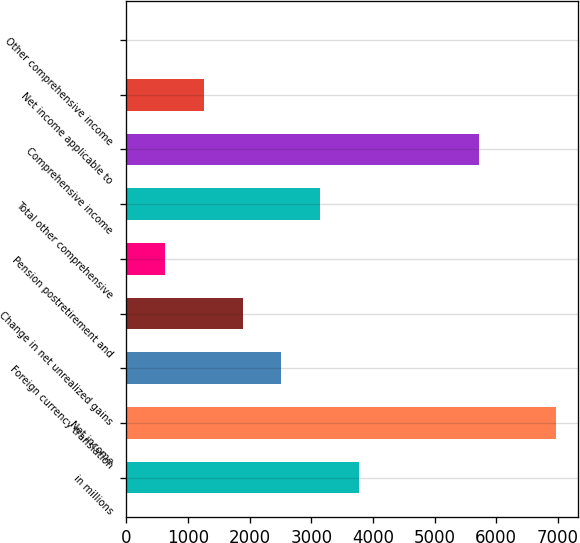Convert chart to OTSL. <chart><loc_0><loc_0><loc_500><loc_500><bar_chart><fcel>in millions<fcel>Net income<fcel>Foreign currency translation<fcel>Change in net unrealized gains<fcel>Pension postretirement and<fcel>Total other comprehensive<fcel>Comprehensive income<fcel>Net income applicable to<fcel>Other comprehensive income<nl><fcel>3769<fcel>6974<fcel>2514<fcel>1886.5<fcel>631.5<fcel>3141.5<fcel>5719<fcel>1259<fcel>4<nl></chart> 